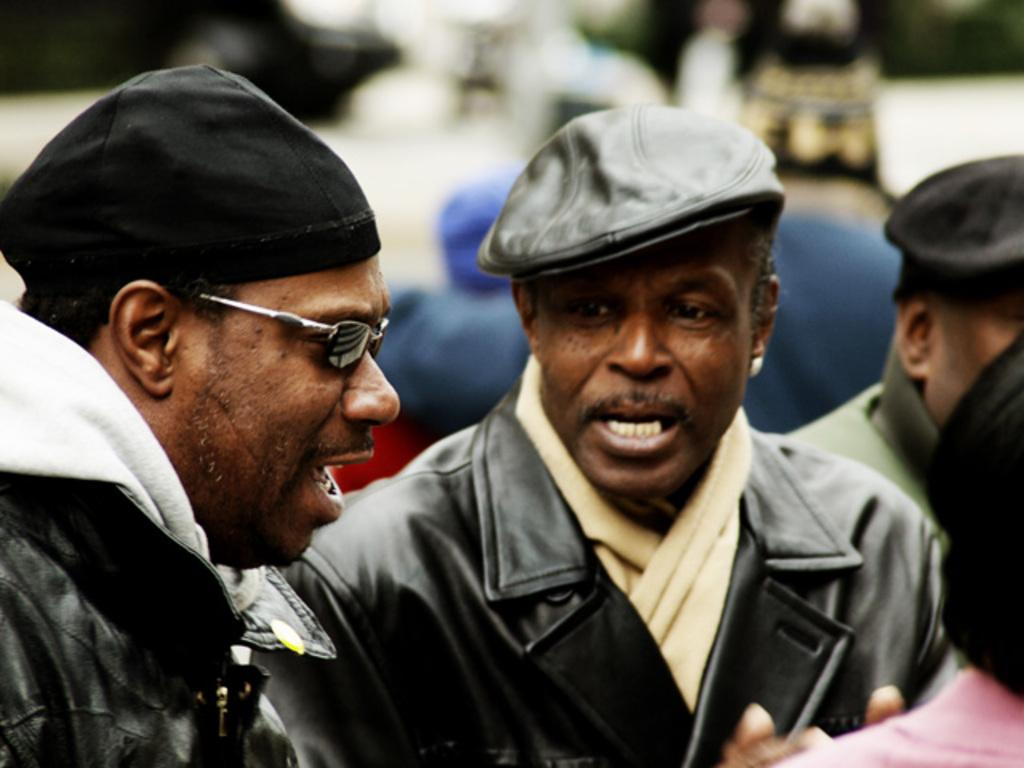How many men are in the foreground of the picture? There are two men in the foreground of the picture. What are the men wearing? The men are wearing black jackets. What are the men doing in the image? The men are talking. Can you describe the people on the right side of the image? There are two persons on the right side of the image. What is the condition of the background in the image? The background of the image is blurred. Are there any other people visible in the image? Yes, there are people visible in the background of the image. What type of toothpaste is being used by the men in the image? There is no toothpaste present in the image; the men are talking while wearing black jackets. How many oranges are visible on the right side of the image? There are no oranges present in the image. 